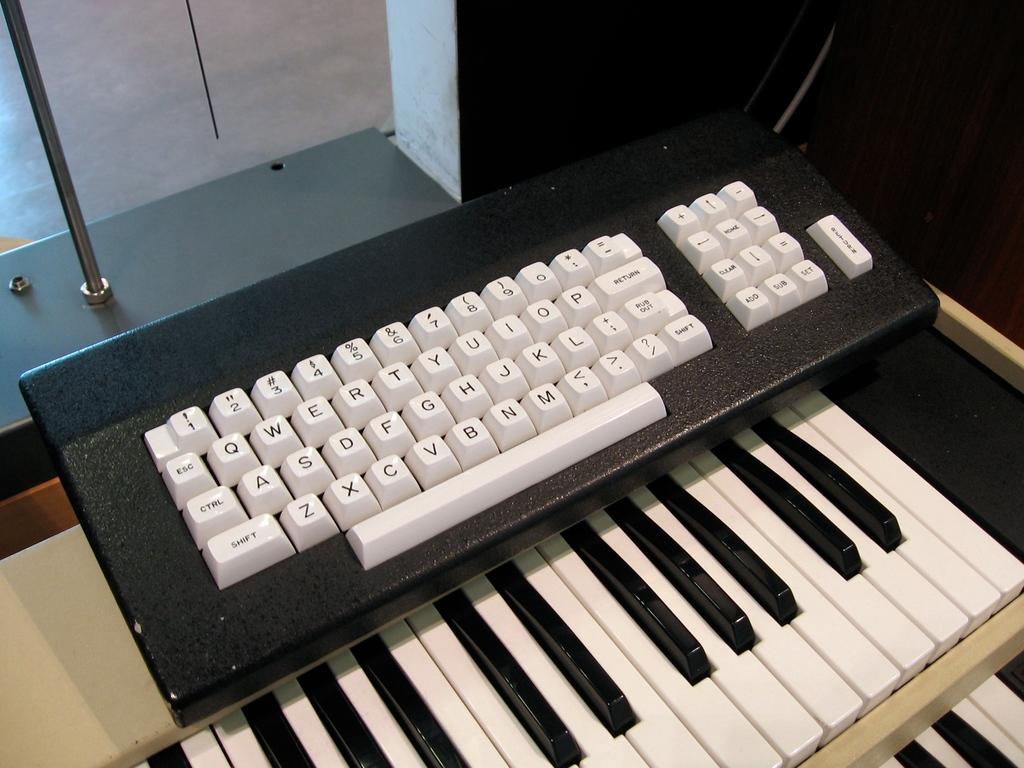What musical instrument is visible in the image? There is a keyboard in the image. Are there any additional features related to the keyboard? Yes, there is a piano keyboard of two steps under the main keyboard. What can be seen in the background of the image? There is a wall and a pole in the background of the image. How would you describe the lighting in the image? The background of the image is dark. Where are the cherries placed on the keyboard in the image? There are no cherries present in the image. What type of toothpaste is used to clean the piano keyboard in the image? There is no toothpaste or cleaning activity depicted in the image. 